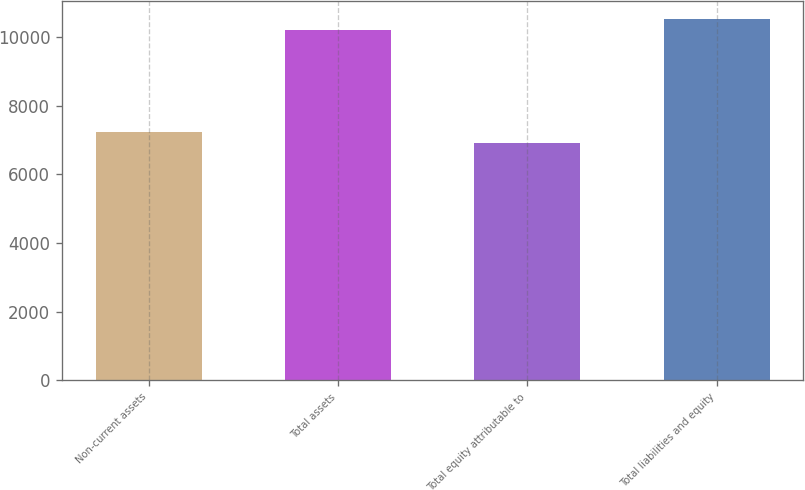Convert chart to OTSL. <chart><loc_0><loc_0><loc_500><loc_500><bar_chart><fcel>Non-current assets<fcel>Total assets<fcel>Total equity attributable to<fcel>Total liabilities and equity<nl><fcel>7241.77<fcel>10201.6<fcel>6912.9<fcel>10530.5<nl></chart> 